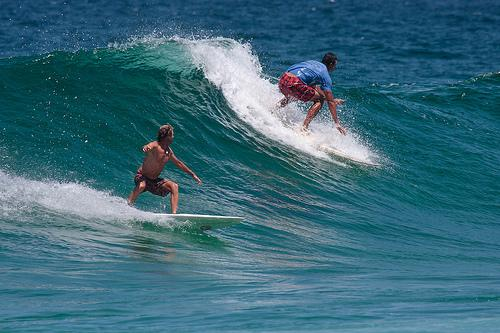What patterns and colors are the man's shorts in the image? The man's shorts have a red and black checkered pattern. Describe the appearance of the wave being surfed by the man in the image. The wave is blue, large, and beginning to break, forming a tube with a whitecap on top. Why is the man's hands in a specific position in the image? The man's hands are positioned to balance and maintain stability while surfing the wave. Analyze the man's surfing stance in the image and comment on his prowess. The man is surfing with a goofy footed stance, which may suggest more experience or skill in surfing. What type of water body is the man surfing in, and what is its general condition? The man is surfing in the ocean, which is very blue and has large waves. What colors is the man wearing while surfing in the image? The man is wearing a blue shirt, red and black checkered shorts, and a shiny object on his chest. Provide a brief description of the main activity taking place in the image. A shirtless surfer is riding a wave on a long white surfboard and reaching towards it for balance. Enumerate the colors that are dominating the ocean scene in the image. The dominant colors in the ocean scene are blue and white. Estimate the number of water splashes present in the image. There are at least three splashes of beach water. Identify the unique features of the surfboard in the image. The surfboard is long, white, and appears to have a black decal and blue fins. What type of shirt is the man wearing, and is it wet or dry? Blue t-shirt, soaking wet What is the man doing with his hands while surfing? Balancing the ride Provide an artistic description of the scene in the image. A talented surfer gracefully skims through the vibrant blue waters, riding the powerful wave as it forms a perfect tube, his long white surfboard being his ally to conquer the thrilling challenge. Describe the type of shorts the man is wearing. Red and black checkered shorts or plaid jams What color is the ocean in the image? Blue Which of these statements best describes the surfboard: (a) red and long, (b) short and green, (c) white and long, (d) black and short? (c) white and long Explain the position of the surfers in relation to the wave. Catching the same wave, one surfer is riding the wave, and the other is reaching for his surfboard. What type of object does the man have on his chest? Shiny object, possibly a necklace Describe the waves in the image. Breaking, forming a tube, whitecaps, and very blue What is the man trying to do with the surfboard? Catch a wave Is there a splash of beach water in the image? If yes, provide its position coordinates. Yes, multiple splashes (X:21 Y:132), (X:64 Y:175), (X:34 Y:172) Provide a short caption summarizing the image. A surfer in a blue shirt and checkered shorts catches a wave on a long white surfboard. Identify the man's stance while surfing. Goofy footed Is there any textual information available in the image? If yes, provide its content. No textual information is present in the image. Is the man goofy footed while he surfs? Yes Is the man surfing on a long or short surfboard? Long surfboard Describe the appearance of the wave in the image. Large, blue, breaking, and forming a tube 